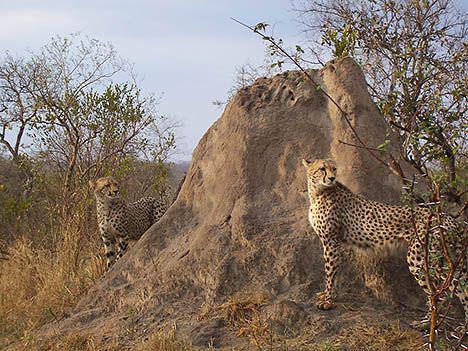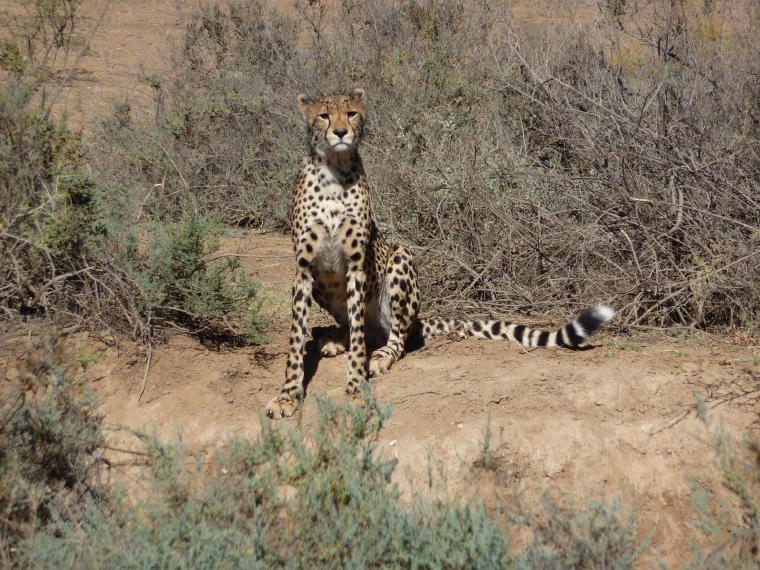The first image is the image on the left, the second image is the image on the right. Given the left and right images, does the statement "The left image shows at least one cheetah standing in front of mounded dirt, and the right image contains just one cheetah." hold true? Answer yes or no. Yes. The first image is the image on the left, the second image is the image on the right. For the images shown, is this caption "There are exactly three cheetahs in the left image." true? Answer yes or no. No. 